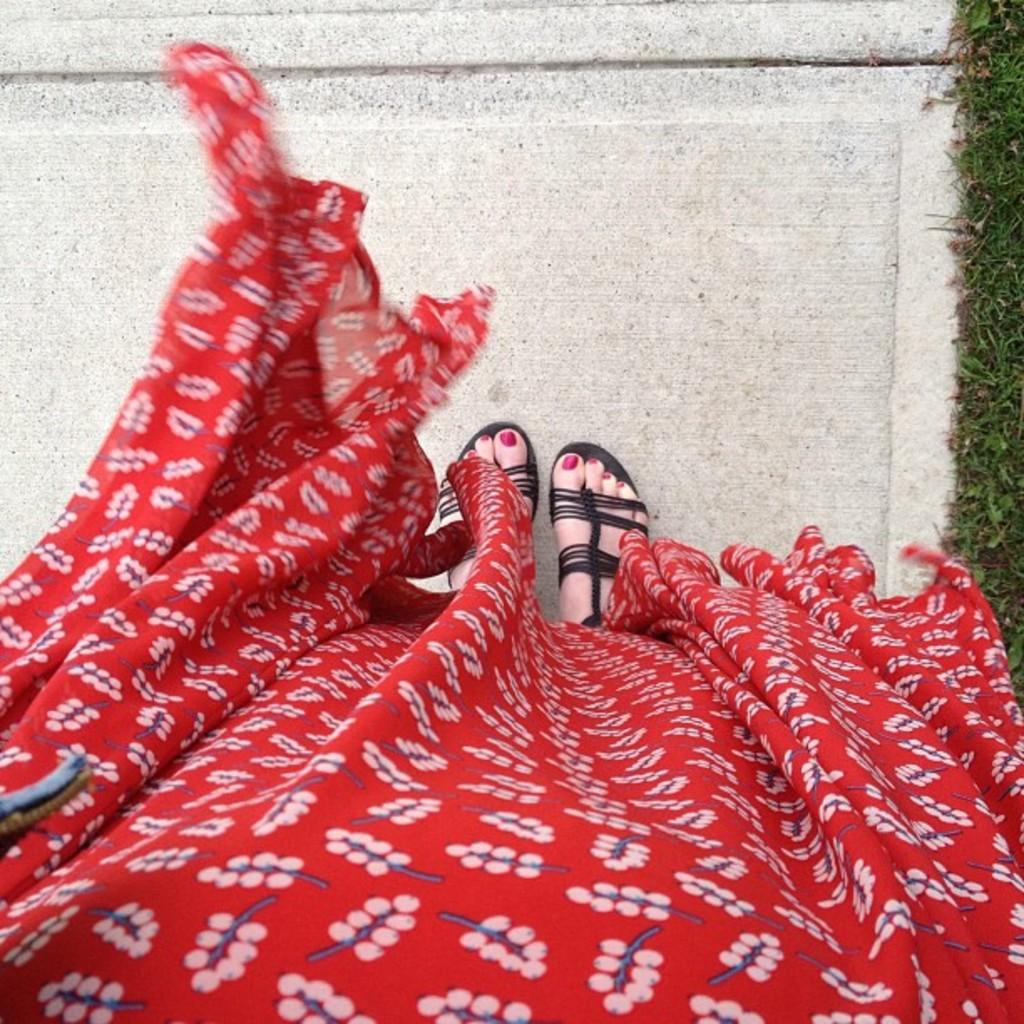Who is the main subject in the image? There is a woman in the image. What is the woman wearing? The woman is wearing a red dress. What part of the woman's body is visible in the image? The woman's legs are visible in the image. What is the woman standing on? The woman is standing on the floor. What type of vegetation can be seen on the right side of the image? There is grass on the right side of the image. How many planes are flying over the woman's head in the image? There are no planes visible in the image; it only features a woman standing on the floor with grass on the right side. 